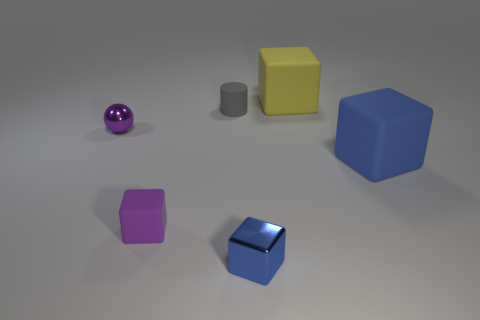Is there anything else that has the same color as the metallic sphere?
Provide a succinct answer. Yes. What size is the thing that is the same color as the shiny cube?
Your answer should be very brief. Large. There is a thing on the left side of the small purple rubber cube; is its color the same as the tiny rubber cube?
Make the answer very short. Yes. The purple metal thing has what size?
Keep it short and to the point. Small. There is a rubber cube that is behind the large matte object in front of the small shiny sphere; are there any large blocks that are in front of it?
Offer a very short reply. Yes. What number of things are right of the large yellow matte cube?
Your answer should be compact. 1. What number of large matte blocks are the same color as the shiny block?
Your answer should be very brief. 1. What number of things are either things left of the blue metal cube or metallic cubes that are to the left of the large blue matte thing?
Your answer should be very brief. 4. Is the number of blue blocks greater than the number of purple metallic balls?
Offer a very short reply. Yes. There is a tiny metal object that is in front of the small purple rubber thing; what color is it?
Provide a short and direct response. Blue. 